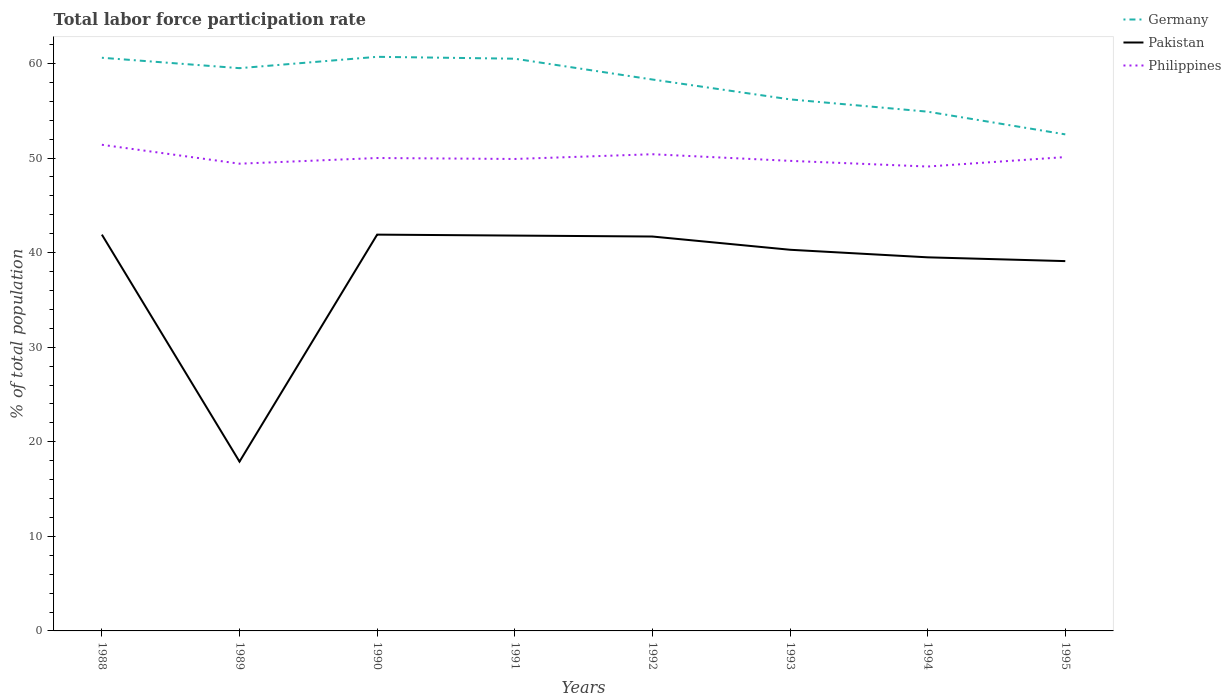Is the number of lines equal to the number of legend labels?
Offer a very short reply. Yes. Across all years, what is the maximum total labor force participation rate in Germany?
Keep it short and to the point. 52.5. What is the total total labor force participation rate in Germany in the graph?
Offer a terse response. 5.8. What is the difference between the highest and the second highest total labor force participation rate in Germany?
Your response must be concise. 8.2. What is the difference between the highest and the lowest total labor force participation rate in Philippines?
Ensure brevity in your answer.  3. How many lines are there?
Keep it short and to the point. 3. How many legend labels are there?
Offer a very short reply. 3. What is the title of the graph?
Your response must be concise. Total labor force participation rate. What is the label or title of the X-axis?
Offer a terse response. Years. What is the label or title of the Y-axis?
Offer a very short reply. % of total population. What is the % of total population in Germany in 1988?
Ensure brevity in your answer.  60.6. What is the % of total population in Pakistan in 1988?
Your response must be concise. 41.9. What is the % of total population of Philippines in 1988?
Give a very brief answer. 51.4. What is the % of total population in Germany in 1989?
Give a very brief answer. 59.5. What is the % of total population of Pakistan in 1989?
Provide a succinct answer. 17.9. What is the % of total population of Philippines in 1989?
Provide a succinct answer. 49.4. What is the % of total population in Germany in 1990?
Keep it short and to the point. 60.7. What is the % of total population in Pakistan in 1990?
Make the answer very short. 41.9. What is the % of total population in Germany in 1991?
Keep it short and to the point. 60.5. What is the % of total population in Pakistan in 1991?
Provide a short and direct response. 41.8. What is the % of total population in Philippines in 1991?
Offer a very short reply. 49.9. What is the % of total population in Germany in 1992?
Your answer should be compact. 58.3. What is the % of total population of Pakistan in 1992?
Provide a short and direct response. 41.7. What is the % of total population in Philippines in 1992?
Your answer should be very brief. 50.4. What is the % of total population of Germany in 1993?
Provide a short and direct response. 56.2. What is the % of total population in Pakistan in 1993?
Give a very brief answer. 40.3. What is the % of total population in Philippines in 1993?
Offer a very short reply. 49.7. What is the % of total population of Germany in 1994?
Give a very brief answer. 54.9. What is the % of total population of Pakistan in 1994?
Make the answer very short. 39.5. What is the % of total population in Philippines in 1994?
Give a very brief answer. 49.1. What is the % of total population of Germany in 1995?
Provide a short and direct response. 52.5. What is the % of total population of Pakistan in 1995?
Provide a succinct answer. 39.1. What is the % of total population of Philippines in 1995?
Give a very brief answer. 50.1. Across all years, what is the maximum % of total population of Germany?
Your answer should be compact. 60.7. Across all years, what is the maximum % of total population of Pakistan?
Provide a short and direct response. 41.9. Across all years, what is the maximum % of total population in Philippines?
Offer a terse response. 51.4. Across all years, what is the minimum % of total population of Germany?
Offer a very short reply. 52.5. Across all years, what is the minimum % of total population in Pakistan?
Offer a very short reply. 17.9. Across all years, what is the minimum % of total population of Philippines?
Ensure brevity in your answer.  49.1. What is the total % of total population in Germany in the graph?
Offer a terse response. 463.2. What is the total % of total population of Pakistan in the graph?
Your answer should be compact. 304.1. What is the total % of total population of Philippines in the graph?
Keep it short and to the point. 400. What is the difference between the % of total population in Pakistan in 1988 and that in 1989?
Your response must be concise. 24. What is the difference between the % of total population in Pakistan in 1988 and that in 1990?
Ensure brevity in your answer.  0. What is the difference between the % of total population in Philippines in 1988 and that in 1990?
Offer a terse response. 1.4. What is the difference between the % of total population in Pakistan in 1988 and that in 1991?
Provide a short and direct response. 0.1. What is the difference between the % of total population of Pakistan in 1988 and that in 1992?
Your answer should be compact. 0.2. What is the difference between the % of total population of Philippines in 1988 and that in 1992?
Provide a succinct answer. 1. What is the difference between the % of total population of Germany in 1988 and that in 1993?
Keep it short and to the point. 4.4. What is the difference between the % of total population of Pakistan in 1988 and that in 1993?
Offer a terse response. 1.6. What is the difference between the % of total population in Germany in 1988 and that in 1994?
Give a very brief answer. 5.7. What is the difference between the % of total population in Pakistan in 1988 and that in 1994?
Offer a terse response. 2.4. What is the difference between the % of total population in Germany in 1988 and that in 1995?
Keep it short and to the point. 8.1. What is the difference between the % of total population of Pakistan in 1989 and that in 1990?
Offer a very short reply. -24. What is the difference between the % of total population of Germany in 1989 and that in 1991?
Provide a succinct answer. -1. What is the difference between the % of total population in Pakistan in 1989 and that in 1991?
Offer a terse response. -23.9. What is the difference between the % of total population in Philippines in 1989 and that in 1991?
Make the answer very short. -0.5. What is the difference between the % of total population in Pakistan in 1989 and that in 1992?
Your answer should be very brief. -23.8. What is the difference between the % of total population in Philippines in 1989 and that in 1992?
Your answer should be compact. -1. What is the difference between the % of total population of Pakistan in 1989 and that in 1993?
Make the answer very short. -22.4. What is the difference between the % of total population of Philippines in 1989 and that in 1993?
Offer a terse response. -0.3. What is the difference between the % of total population in Pakistan in 1989 and that in 1994?
Your answer should be very brief. -21.6. What is the difference between the % of total population in Philippines in 1989 and that in 1994?
Your response must be concise. 0.3. What is the difference between the % of total population in Germany in 1989 and that in 1995?
Keep it short and to the point. 7. What is the difference between the % of total population of Pakistan in 1989 and that in 1995?
Offer a very short reply. -21.2. What is the difference between the % of total population of Philippines in 1989 and that in 1995?
Give a very brief answer. -0.7. What is the difference between the % of total population in Germany in 1990 and that in 1992?
Make the answer very short. 2.4. What is the difference between the % of total population of Pakistan in 1990 and that in 1992?
Provide a short and direct response. 0.2. What is the difference between the % of total population in Philippines in 1990 and that in 1992?
Provide a short and direct response. -0.4. What is the difference between the % of total population of Germany in 1990 and that in 1993?
Offer a terse response. 4.5. What is the difference between the % of total population of Philippines in 1990 and that in 1993?
Keep it short and to the point. 0.3. What is the difference between the % of total population in Germany in 1990 and that in 1994?
Provide a succinct answer. 5.8. What is the difference between the % of total population of Pakistan in 1990 and that in 1994?
Keep it short and to the point. 2.4. What is the difference between the % of total population of Philippines in 1990 and that in 1994?
Offer a terse response. 0.9. What is the difference between the % of total population of Philippines in 1991 and that in 1992?
Offer a terse response. -0.5. What is the difference between the % of total population in Germany in 1991 and that in 1993?
Ensure brevity in your answer.  4.3. What is the difference between the % of total population of Pakistan in 1991 and that in 1993?
Your response must be concise. 1.5. What is the difference between the % of total population of Germany in 1991 and that in 1994?
Offer a terse response. 5.6. What is the difference between the % of total population in Pakistan in 1991 and that in 1994?
Give a very brief answer. 2.3. What is the difference between the % of total population of Philippines in 1991 and that in 1994?
Keep it short and to the point. 0.8. What is the difference between the % of total population in Germany in 1991 and that in 1995?
Provide a short and direct response. 8. What is the difference between the % of total population in Philippines in 1991 and that in 1995?
Give a very brief answer. -0.2. What is the difference between the % of total population of Germany in 1992 and that in 1993?
Make the answer very short. 2.1. What is the difference between the % of total population of Germany in 1992 and that in 1994?
Your answer should be very brief. 3.4. What is the difference between the % of total population of Pakistan in 1992 and that in 1994?
Ensure brevity in your answer.  2.2. What is the difference between the % of total population of Germany in 1992 and that in 1995?
Keep it short and to the point. 5.8. What is the difference between the % of total population in Pakistan in 1992 and that in 1995?
Offer a terse response. 2.6. What is the difference between the % of total population in Philippines in 1992 and that in 1995?
Give a very brief answer. 0.3. What is the difference between the % of total population of Pakistan in 1993 and that in 1994?
Your answer should be very brief. 0.8. What is the difference between the % of total population of Pakistan in 1993 and that in 1995?
Your response must be concise. 1.2. What is the difference between the % of total population in Germany in 1988 and the % of total population in Pakistan in 1989?
Your answer should be compact. 42.7. What is the difference between the % of total population in Germany in 1988 and the % of total population in Philippines in 1989?
Ensure brevity in your answer.  11.2. What is the difference between the % of total population of Germany in 1988 and the % of total population of Pakistan in 1990?
Provide a short and direct response. 18.7. What is the difference between the % of total population of Germany in 1988 and the % of total population of Philippines in 1991?
Make the answer very short. 10.7. What is the difference between the % of total population of Germany in 1988 and the % of total population of Philippines in 1992?
Keep it short and to the point. 10.2. What is the difference between the % of total population of Germany in 1988 and the % of total population of Pakistan in 1993?
Keep it short and to the point. 20.3. What is the difference between the % of total population in Germany in 1988 and the % of total population in Philippines in 1993?
Ensure brevity in your answer.  10.9. What is the difference between the % of total population in Germany in 1988 and the % of total population in Pakistan in 1994?
Provide a short and direct response. 21.1. What is the difference between the % of total population in Germany in 1988 and the % of total population in Philippines in 1994?
Provide a succinct answer. 11.5. What is the difference between the % of total population of Pakistan in 1988 and the % of total population of Philippines in 1994?
Your answer should be compact. -7.2. What is the difference between the % of total population of Germany in 1988 and the % of total population of Pakistan in 1995?
Offer a terse response. 21.5. What is the difference between the % of total population in Germany in 1988 and the % of total population in Philippines in 1995?
Your answer should be compact. 10.5. What is the difference between the % of total population in Germany in 1989 and the % of total population in Pakistan in 1990?
Your answer should be very brief. 17.6. What is the difference between the % of total population in Germany in 1989 and the % of total population in Philippines in 1990?
Offer a very short reply. 9.5. What is the difference between the % of total population of Pakistan in 1989 and the % of total population of Philippines in 1990?
Your answer should be very brief. -32.1. What is the difference between the % of total population of Germany in 1989 and the % of total population of Philippines in 1991?
Your answer should be compact. 9.6. What is the difference between the % of total population in Pakistan in 1989 and the % of total population in Philippines in 1991?
Your answer should be compact. -32. What is the difference between the % of total population of Germany in 1989 and the % of total population of Pakistan in 1992?
Offer a terse response. 17.8. What is the difference between the % of total population in Germany in 1989 and the % of total population in Philippines in 1992?
Your response must be concise. 9.1. What is the difference between the % of total population in Pakistan in 1989 and the % of total population in Philippines in 1992?
Provide a succinct answer. -32.5. What is the difference between the % of total population of Germany in 1989 and the % of total population of Pakistan in 1993?
Your answer should be compact. 19.2. What is the difference between the % of total population in Pakistan in 1989 and the % of total population in Philippines in 1993?
Give a very brief answer. -31.8. What is the difference between the % of total population in Germany in 1989 and the % of total population in Philippines in 1994?
Ensure brevity in your answer.  10.4. What is the difference between the % of total population in Pakistan in 1989 and the % of total population in Philippines in 1994?
Give a very brief answer. -31.2. What is the difference between the % of total population in Germany in 1989 and the % of total population in Pakistan in 1995?
Make the answer very short. 20.4. What is the difference between the % of total population of Pakistan in 1989 and the % of total population of Philippines in 1995?
Keep it short and to the point. -32.2. What is the difference between the % of total population of Germany in 1990 and the % of total population of Pakistan in 1991?
Provide a succinct answer. 18.9. What is the difference between the % of total population of Germany in 1990 and the % of total population of Philippines in 1992?
Provide a short and direct response. 10.3. What is the difference between the % of total population in Germany in 1990 and the % of total population in Pakistan in 1993?
Your answer should be very brief. 20.4. What is the difference between the % of total population of Germany in 1990 and the % of total population of Pakistan in 1994?
Ensure brevity in your answer.  21.2. What is the difference between the % of total population of Germany in 1990 and the % of total population of Pakistan in 1995?
Provide a short and direct response. 21.6. What is the difference between the % of total population in Pakistan in 1990 and the % of total population in Philippines in 1995?
Give a very brief answer. -8.2. What is the difference between the % of total population in Germany in 1991 and the % of total population in Pakistan in 1993?
Ensure brevity in your answer.  20.2. What is the difference between the % of total population in Germany in 1991 and the % of total population in Philippines in 1993?
Your answer should be compact. 10.8. What is the difference between the % of total population in Germany in 1991 and the % of total population in Pakistan in 1995?
Ensure brevity in your answer.  21.4. What is the difference between the % of total population in Germany in 1991 and the % of total population in Philippines in 1995?
Offer a very short reply. 10.4. What is the difference between the % of total population in Germany in 1992 and the % of total population in Pakistan in 1994?
Give a very brief answer. 18.8. What is the difference between the % of total population in Germany in 1992 and the % of total population in Philippines in 1994?
Provide a short and direct response. 9.2. What is the difference between the % of total population of Germany in 1992 and the % of total population of Philippines in 1995?
Give a very brief answer. 8.2. What is the difference between the % of total population in Pakistan in 1992 and the % of total population in Philippines in 1995?
Your answer should be very brief. -8.4. What is the difference between the % of total population of Germany in 1993 and the % of total population of Pakistan in 1994?
Your answer should be compact. 16.7. What is the difference between the % of total population of Germany in 1994 and the % of total population of Pakistan in 1995?
Offer a terse response. 15.8. What is the average % of total population in Germany per year?
Ensure brevity in your answer.  57.9. What is the average % of total population in Pakistan per year?
Offer a terse response. 38.01. In the year 1988, what is the difference between the % of total population in Germany and % of total population in Philippines?
Provide a short and direct response. 9.2. In the year 1989, what is the difference between the % of total population of Germany and % of total population of Pakistan?
Make the answer very short. 41.6. In the year 1989, what is the difference between the % of total population in Pakistan and % of total population in Philippines?
Your answer should be compact. -31.5. In the year 1990, what is the difference between the % of total population of Germany and % of total population of Pakistan?
Your response must be concise. 18.8. In the year 1990, what is the difference between the % of total population in Germany and % of total population in Philippines?
Your answer should be very brief. 10.7. In the year 1991, what is the difference between the % of total population in Pakistan and % of total population in Philippines?
Your answer should be very brief. -8.1. In the year 1992, what is the difference between the % of total population in Germany and % of total population in Philippines?
Give a very brief answer. 7.9. In the year 1992, what is the difference between the % of total population in Pakistan and % of total population in Philippines?
Provide a short and direct response. -8.7. In the year 1993, what is the difference between the % of total population of Germany and % of total population of Pakistan?
Offer a terse response. 15.9. In the year 1993, what is the difference between the % of total population in Germany and % of total population in Philippines?
Offer a very short reply. 6.5. In the year 1994, what is the difference between the % of total population in Germany and % of total population in Pakistan?
Make the answer very short. 15.4. In the year 1994, what is the difference between the % of total population of Germany and % of total population of Philippines?
Offer a terse response. 5.8. In the year 1995, what is the difference between the % of total population of Germany and % of total population of Pakistan?
Keep it short and to the point. 13.4. What is the ratio of the % of total population in Germany in 1988 to that in 1989?
Make the answer very short. 1.02. What is the ratio of the % of total population of Pakistan in 1988 to that in 1989?
Offer a very short reply. 2.34. What is the ratio of the % of total population of Philippines in 1988 to that in 1989?
Your answer should be very brief. 1.04. What is the ratio of the % of total population in Germany in 1988 to that in 1990?
Your answer should be very brief. 1. What is the ratio of the % of total population of Pakistan in 1988 to that in 1990?
Give a very brief answer. 1. What is the ratio of the % of total population in Philippines in 1988 to that in 1990?
Give a very brief answer. 1.03. What is the ratio of the % of total population in Germany in 1988 to that in 1991?
Offer a very short reply. 1. What is the ratio of the % of total population of Pakistan in 1988 to that in 1991?
Your answer should be compact. 1. What is the ratio of the % of total population in Philippines in 1988 to that in 1991?
Offer a terse response. 1.03. What is the ratio of the % of total population in Germany in 1988 to that in 1992?
Your answer should be compact. 1.04. What is the ratio of the % of total population of Philippines in 1988 to that in 1992?
Provide a short and direct response. 1.02. What is the ratio of the % of total population in Germany in 1988 to that in 1993?
Offer a very short reply. 1.08. What is the ratio of the % of total population in Pakistan in 1988 to that in 1993?
Your response must be concise. 1.04. What is the ratio of the % of total population in Philippines in 1988 to that in 1993?
Keep it short and to the point. 1.03. What is the ratio of the % of total population of Germany in 1988 to that in 1994?
Give a very brief answer. 1.1. What is the ratio of the % of total population of Pakistan in 1988 to that in 1994?
Your response must be concise. 1.06. What is the ratio of the % of total population in Philippines in 1988 to that in 1994?
Keep it short and to the point. 1.05. What is the ratio of the % of total population of Germany in 1988 to that in 1995?
Give a very brief answer. 1.15. What is the ratio of the % of total population in Pakistan in 1988 to that in 1995?
Offer a terse response. 1.07. What is the ratio of the % of total population of Philippines in 1988 to that in 1995?
Your answer should be very brief. 1.03. What is the ratio of the % of total population of Germany in 1989 to that in 1990?
Offer a terse response. 0.98. What is the ratio of the % of total population of Pakistan in 1989 to that in 1990?
Provide a succinct answer. 0.43. What is the ratio of the % of total population in Philippines in 1989 to that in 1990?
Provide a succinct answer. 0.99. What is the ratio of the % of total population in Germany in 1989 to that in 1991?
Make the answer very short. 0.98. What is the ratio of the % of total population of Pakistan in 1989 to that in 1991?
Offer a very short reply. 0.43. What is the ratio of the % of total population in Germany in 1989 to that in 1992?
Your answer should be compact. 1.02. What is the ratio of the % of total population in Pakistan in 1989 to that in 1992?
Your answer should be compact. 0.43. What is the ratio of the % of total population of Philippines in 1989 to that in 1992?
Give a very brief answer. 0.98. What is the ratio of the % of total population of Germany in 1989 to that in 1993?
Your answer should be compact. 1.06. What is the ratio of the % of total population of Pakistan in 1989 to that in 1993?
Make the answer very short. 0.44. What is the ratio of the % of total population of Germany in 1989 to that in 1994?
Make the answer very short. 1.08. What is the ratio of the % of total population of Pakistan in 1989 to that in 1994?
Your answer should be very brief. 0.45. What is the ratio of the % of total population of Philippines in 1989 to that in 1994?
Make the answer very short. 1.01. What is the ratio of the % of total population of Germany in 1989 to that in 1995?
Provide a short and direct response. 1.13. What is the ratio of the % of total population in Pakistan in 1989 to that in 1995?
Make the answer very short. 0.46. What is the ratio of the % of total population of Pakistan in 1990 to that in 1991?
Make the answer very short. 1. What is the ratio of the % of total population in Philippines in 1990 to that in 1991?
Your response must be concise. 1. What is the ratio of the % of total population of Germany in 1990 to that in 1992?
Provide a short and direct response. 1.04. What is the ratio of the % of total population in Pakistan in 1990 to that in 1992?
Offer a terse response. 1. What is the ratio of the % of total population in Philippines in 1990 to that in 1992?
Make the answer very short. 0.99. What is the ratio of the % of total population of Germany in 1990 to that in 1993?
Your answer should be very brief. 1.08. What is the ratio of the % of total population in Pakistan in 1990 to that in 1993?
Keep it short and to the point. 1.04. What is the ratio of the % of total population in Germany in 1990 to that in 1994?
Ensure brevity in your answer.  1.11. What is the ratio of the % of total population of Pakistan in 1990 to that in 1994?
Your response must be concise. 1.06. What is the ratio of the % of total population of Philippines in 1990 to that in 1994?
Ensure brevity in your answer.  1.02. What is the ratio of the % of total population in Germany in 1990 to that in 1995?
Give a very brief answer. 1.16. What is the ratio of the % of total population in Pakistan in 1990 to that in 1995?
Offer a very short reply. 1.07. What is the ratio of the % of total population of Germany in 1991 to that in 1992?
Your answer should be very brief. 1.04. What is the ratio of the % of total population of Pakistan in 1991 to that in 1992?
Provide a succinct answer. 1. What is the ratio of the % of total population of Philippines in 1991 to that in 1992?
Make the answer very short. 0.99. What is the ratio of the % of total population of Germany in 1991 to that in 1993?
Keep it short and to the point. 1.08. What is the ratio of the % of total population in Pakistan in 1991 to that in 1993?
Ensure brevity in your answer.  1.04. What is the ratio of the % of total population in Germany in 1991 to that in 1994?
Your answer should be compact. 1.1. What is the ratio of the % of total population of Pakistan in 1991 to that in 1994?
Offer a terse response. 1.06. What is the ratio of the % of total population of Philippines in 1991 to that in 1994?
Keep it short and to the point. 1.02. What is the ratio of the % of total population in Germany in 1991 to that in 1995?
Your answer should be very brief. 1.15. What is the ratio of the % of total population of Pakistan in 1991 to that in 1995?
Make the answer very short. 1.07. What is the ratio of the % of total population in Germany in 1992 to that in 1993?
Your answer should be compact. 1.04. What is the ratio of the % of total population in Pakistan in 1992 to that in 1993?
Provide a succinct answer. 1.03. What is the ratio of the % of total population of Philippines in 1992 to that in 1993?
Your response must be concise. 1.01. What is the ratio of the % of total population in Germany in 1992 to that in 1994?
Provide a short and direct response. 1.06. What is the ratio of the % of total population of Pakistan in 1992 to that in 1994?
Your answer should be compact. 1.06. What is the ratio of the % of total population of Philippines in 1992 to that in 1994?
Ensure brevity in your answer.  1.03. What is the ratio of the % of total population of Germany in 1992 to that in 1995?
Give a very brief answer. 1.11. What is the ratio of the % of total population in Pakistan in 1992 to that in 1995?
Give a very brief answer. 1.07. What is the ratio of the % of total population in Philippines in 1992 to that in 1995?
Ensure brevity in your answer.  1.01. What is the ratio of the % of total population of Germany in 1993 to that in 1994?
Give a very brief answer. 1.02. What is the ratio of the % of total population in Pakistan in 1993 to that in 1994?
Offer a terse response. 1.02. What is the ratio of the % of total population in Philippines in 1993 to that in 1994?
Give a very brief answer. 1.01. What is the ratio of the % of total population of Germany in 1993 to that in 1995?
Keep it short and to the point. 1.07. What is the ratio of the % of total population of Pakistan in 1993 to that in 1995?
Offer a terse response. 1.03. What is the ratio of the % of total population in Germany in 1994 to that in 1995?
Ensure brevity in your answer.  1.05. What is the ratio of the % of total population of Pakistan in 1994 to that in 1995?
Your response must be concise. 1.01. What is the difference between the highest and the second highest % of total population of Germany?
Provide a short and direct response. 0.1. What is the difference between the highest and the lowest % of total population in Pakistan?
Make the answer very short. 24. 